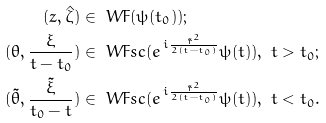Convert formula to latex. <formula><loc_0><loc_0><loc_500><loc_500>( z , \hat { \zeta } ) & \in \ W F ( \psi ( t _ { 0 } ) ) ; \\ ( \theta , \frac { \xi } { t - t _ { 0 } } ) & \in \ W F s c ( e ^ { \, i \frac { \tilde { r } ^ { 2 } } { 2 ( t - t _ { 0 } ) } } \psi ( t ) ) , \ t > t _ { 0 } ; \\ ( \tilde { \theta } , \frac { \tilde { \xi } } { t _ { 0 } - t } ) & \in \ W F s c ( e ^ { \, i \frac { \tilde { r } ^ { 2 } } { 2 ( t - t _ { 0 } ) } } \psi ( t ) ) , \ t < t _ { 0 } .</formula> 